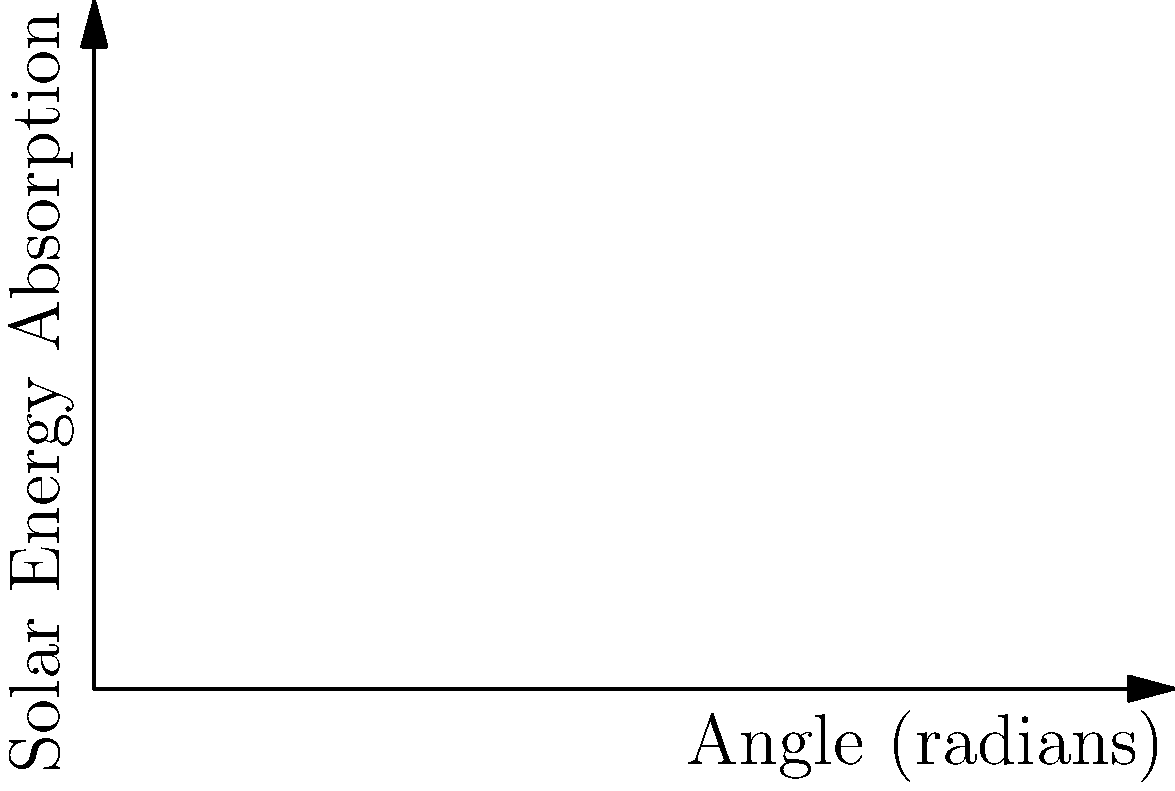As you consider installing solar panels on your barn roof, you want to maximize the energy absorption. The energy absorbed by the panels is proportional to $\sin \theta \cos \theta$, where $\theta$ is the angle of inclination from the horizontal. What is the optimal angle for installing the solar panels to maximize energy absorption? To find the optimal angle, we need to maximize the function $f(\theta) = \sin \theta \cos \theta$.

1) First, recall the trigonometric identity: $\sin 2\theta = 2\sin \theta \cos \theta$

2) This means our function can be rewritten as: $f(\theta) = \frac{1}{2}\sin 2\theta$

3) To find the maximum, we differentiate $f(\theta)$ and set it to zero:

   $f'(\theta) = \frac{1}{2} \cdot 2\cos 2\theta = \cos 2\theta$

4) Setting this to zero:
   $\cos 2\theta = 0$

5) Solving this equation:
   $2\theta = \frac{\pi}{2}$ (since cosine is zero at $\frac{\pi}{2}$)

6) Therefore:
   $\theta = \frac{\pi}{4} = 45°$

7) To confirm this is a maximum (not a minimum), we can check the second derivative:
   $f''(\theta) = -2\sin 2\theta$
   At $\theta = \frac{\pi}{4}$, $f''(\frac{\pi}{4}) = -2\sin(\frac{\pi}{2}) = -2 < 0$

This confirms that $\theta = \frac{\pi}{4}$ gives a maximum.
Answer: $45°$ or $\frac{\pi}{4}$ radians 